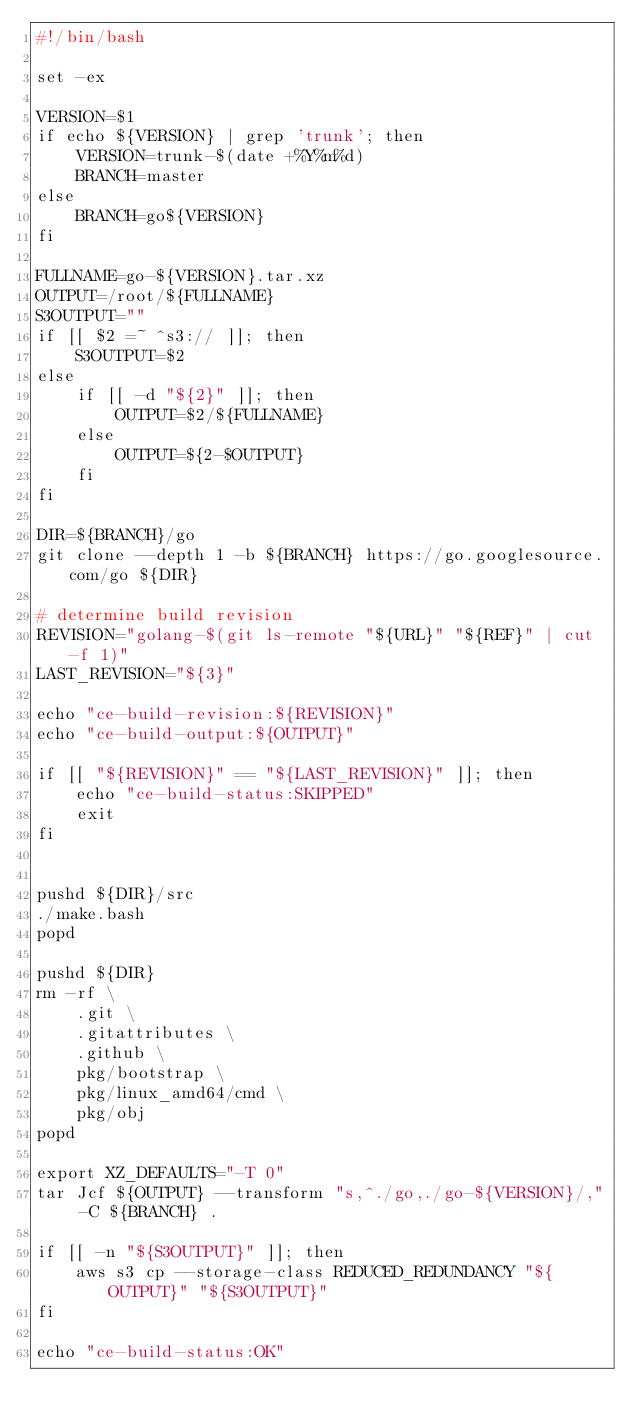<code> <loc_0><loc_0><loc_500><loc_500><_Bash_>#!/bin/bash

set -ex

VERSION=$1
if echo ${VERSION} | grep 'trunk'; then
    VERSION=trunk-$(date +%Y%m%d)
    BRANCH=master
else
    BRANCH=go${VERSION}
fi

FULLNAME=go-${VERSION}.tar.xz
OUTPUT=/root/${FULLNAME}
S3OUTPUT=""
if [[ $2 =~ ^s3:// ]]; then
    S3OUTPUT=$2
else
    if [[ -d "${2}" ]]; then
        OUTPUT=$2/${FULLNAME}
    else
        OUTPUT=${2-$OUTPUT}
    fi
fi

DIR=${BRANCH}/go
git clone --depth 1 -b ${BRANCH} https://go.googlesource.com/go ${DIR}

# determine build revision
REVISION="golang-$(git ls-remote "${URL}" "${REF}" | cut -f 1)"
LAST_REVISION="${3}"

echo "ce-build-revision:${REVISION}"
echo "ce-build-output:${OUTPUT}"

if [[ "${REVISION}" == "${LAST_REVISION}" ]]; then
    echo "ce-build-status:SKIPPED"
    exit
fi


pushd ${DIR}/src
./make.bash
popd

pushd ${DIR}
rm -rf \
    .git \
    .gitattributes \
    .github \
    pkg/bootstrap \
    pkg/linux_amd64/cmd \
    pkg/obj
popd

export XZ_DEFAULTS="-T 0"
tar Jcf ${OUTPUT} --transform "s,^./go,./go-${VERSION}/," -C ${BRANCH} .

if [[ -n "${S3OUTPUT}" ]]; then
    aws s3 cp --storage-class REDUCED_REDUNDANCY "${OUTPUT}" "${S3OUTPUT}"
fi

echo "ce-build-status:OK"
</code> 